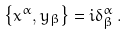Convert formula to latex. <formula><loc_0><loc_0><loc_500><loc_500>\left \{ x ^ { \alpha } , y _ { \beta } \right \} = i \delta _ { \beta } ^ { \alpha } \, .</formula> 